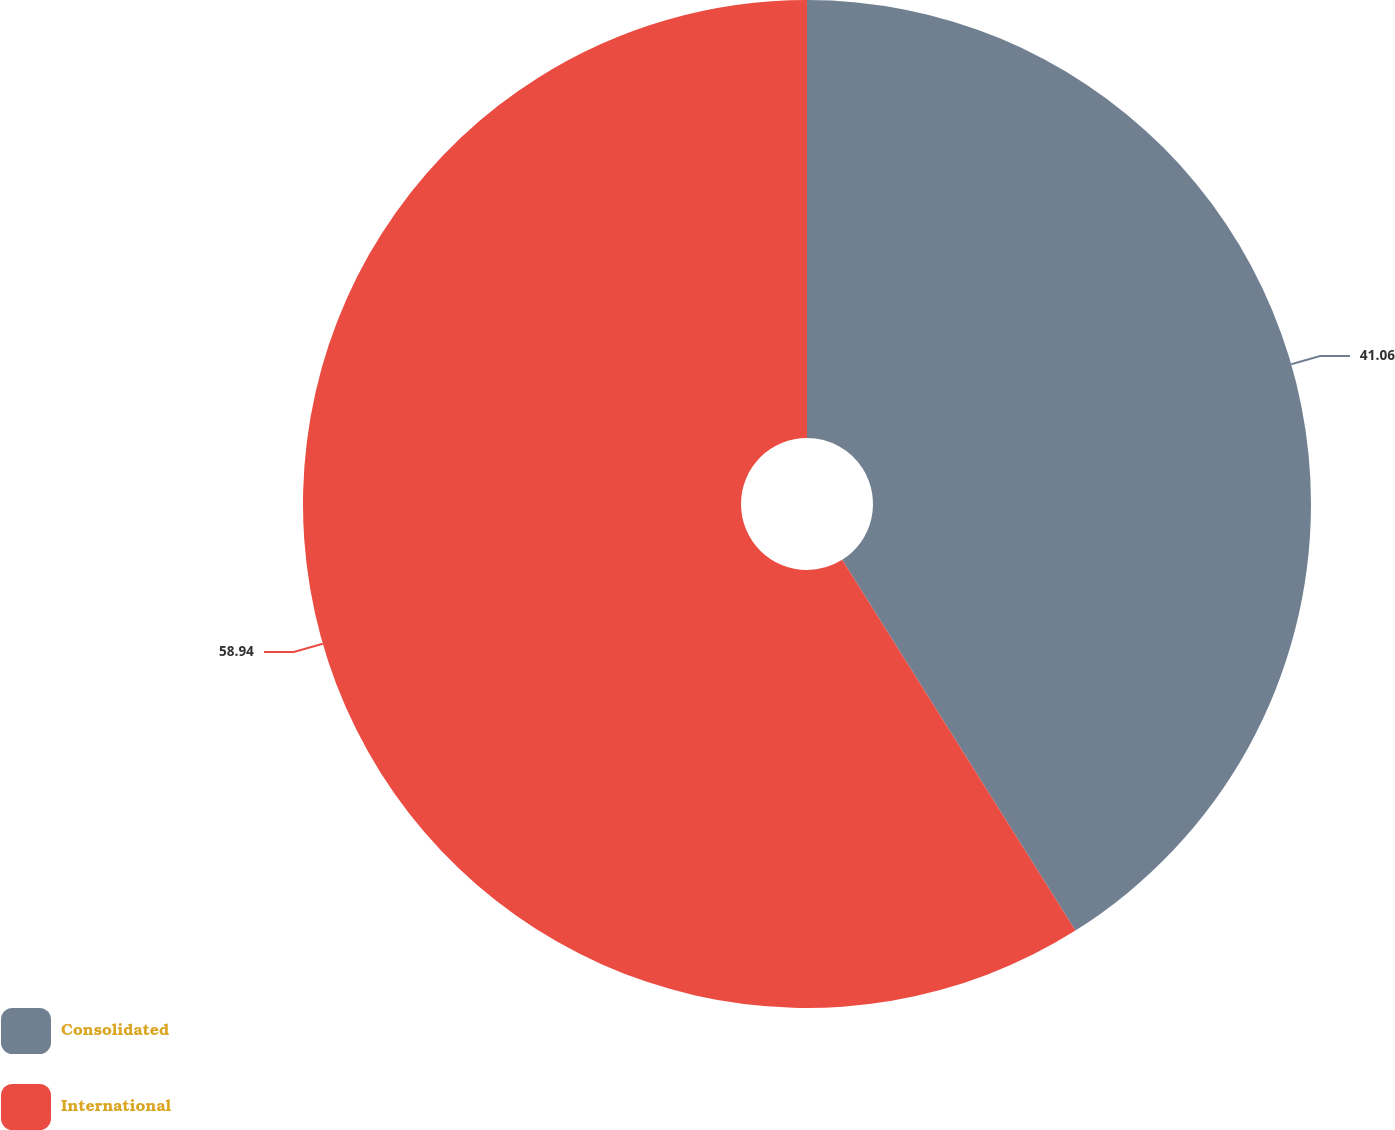Convert chart to OTSL. <chart><loc_0><loc_0><loc_500><loc_500><pie_chart><fcel>Consolidated<fcel>International<nl><fcel>41.06%<fcel>58.94%<nl></chart> 